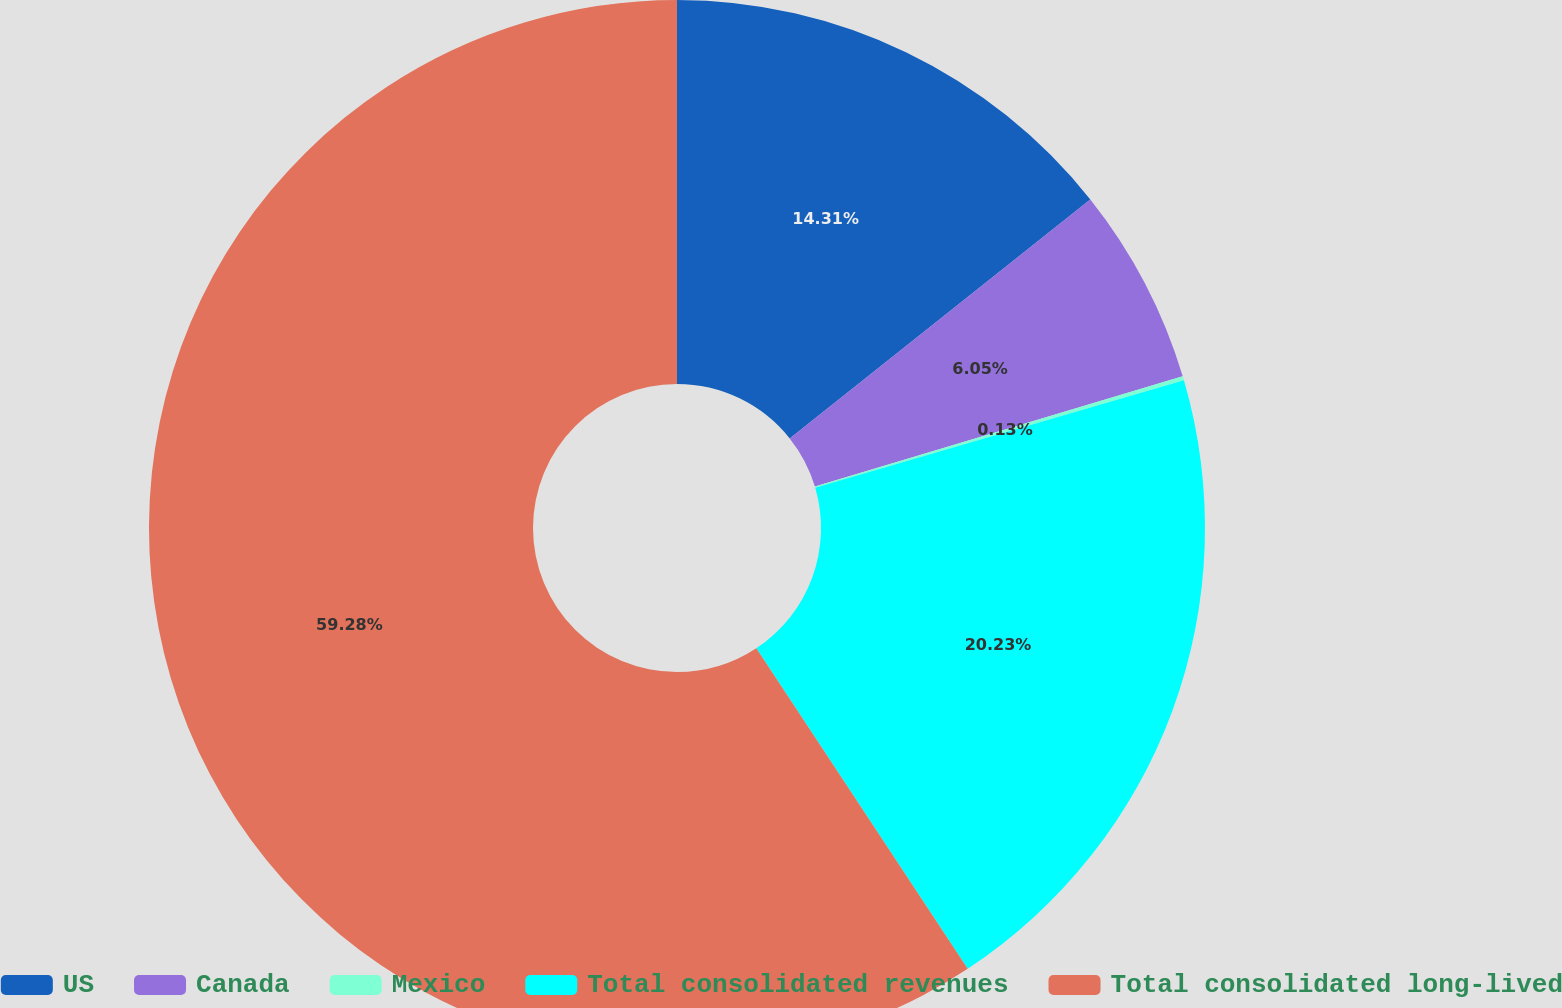<chart> <loc_0><loc_0><loc_500><loc_500><pie_chart><fcel>US<fcel>Canada<fcel>Mexico<fcel>Total consolidated revenues<fcel>Total consolidated long-lived<nl><fcel>14.31%<fcel>6.05%<fcel>0.13%<fcel>20.23%<fcel>59.28%<nl></chart> 